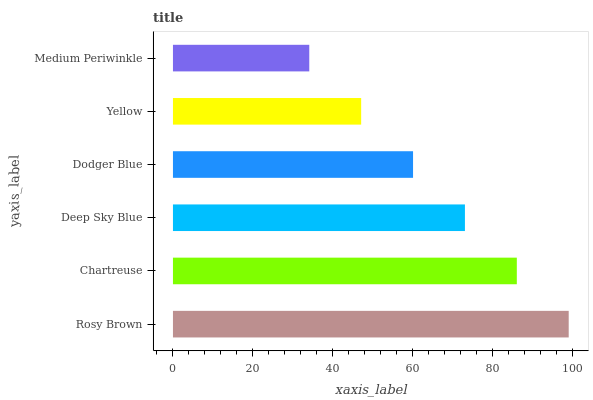Is Medium Periwinkle the minimum?
Answer yes or no. Yes. Is Rosy Brown the maximum?
Answer yes or no. Yes. Is Chartreuse the minimum?
Answer yes or no. No. Is Chartreuse the maximum?
Answer yes or no. No. Is Rosy Brown greater than Chartreuse?
Answer yes or no. Yes. Is Chartreuse less than Rosy Brown?
Answer yes or no. Yes. Is Chartreuse greater than Rosy Brown?
Answer yes or no. No. Is Rosy Brown less than Chartreuse?
Answer yes or no. No. Is Deep Sky Blue the high median?
Answer yes or no. Yes. Is Dodger Blue the low median?
Answer yes or no. Yes. Is Rosy Brown the high median?
Answer yes or no. No. Is Chartreuse the low median?
Answer yes or no. No. 